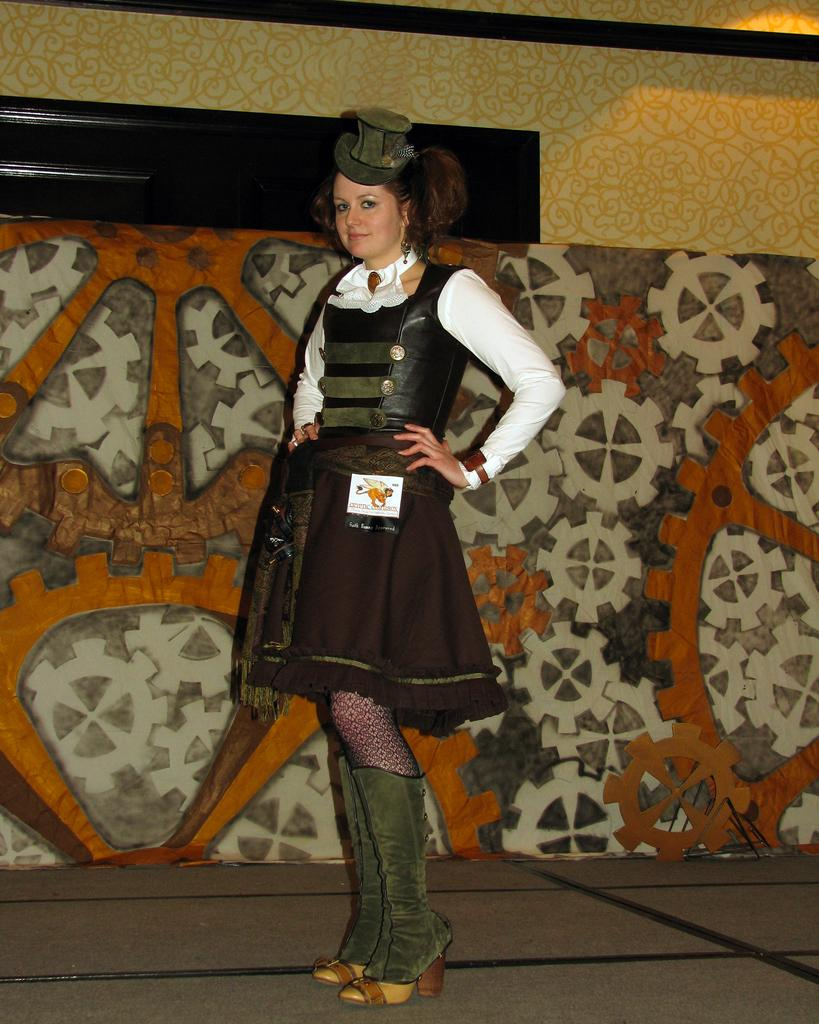Who is present in the image? There is a woman in the image. What is the woman doing in the image? The woman is standing in the image. What is the woman wearing on her head? The woman is wearing a hat in the image. What can be seen in the background of the image? There is a wall visible in the background of the image. What is special about the wall in the image? The wall has a unique design in the image. What type of needle is being used by the woman in the image? There is no needle present in the image; the woman is wearing a hat and standing near a wall with a unique design. 